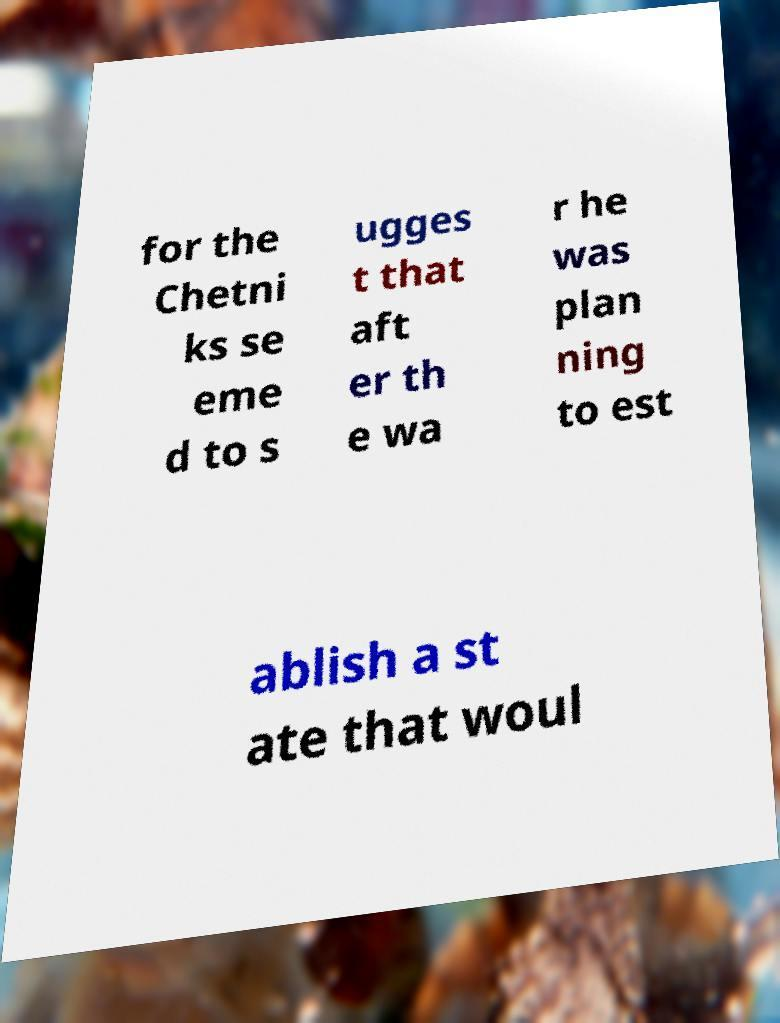Please identify and transcribe the text found in this image. for the Chetni ks se eme d to s ugges t that aft er th e wa r he was plan ning to est ablish a st ate that woul 